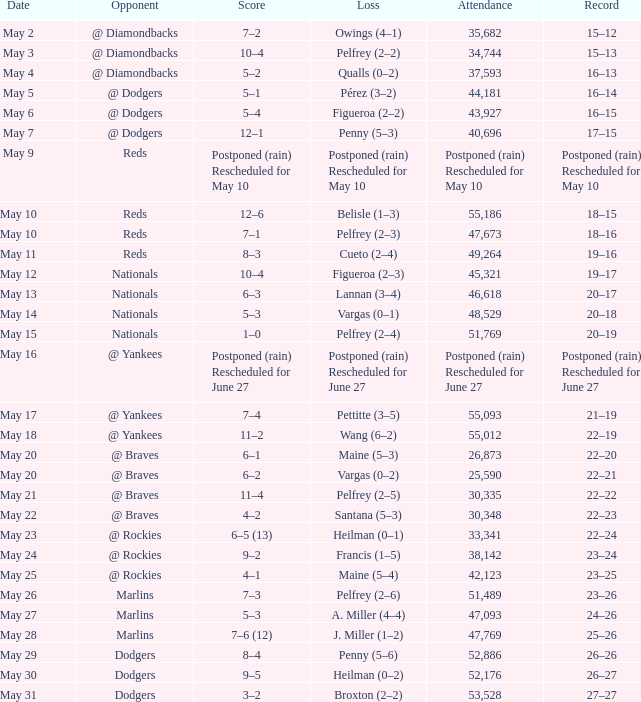Gathering of 30,335 set which record? 22–22. 